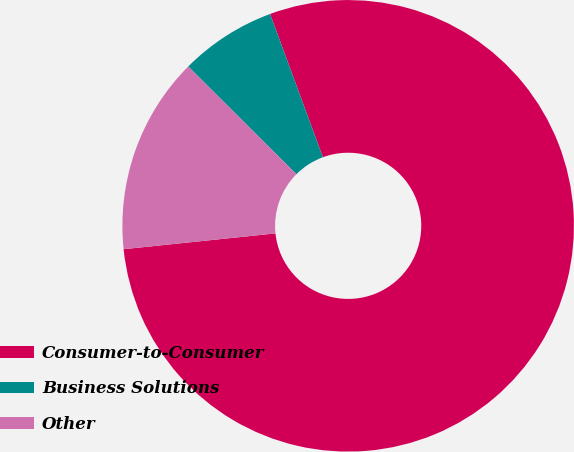<chart> <loc_0><loc_0><loc_500><loc_500><pie_chart><fcel>Consumer-to-Consumer<fcel>Business Solutions<fcel>Other<nl><fcel>78.97%<fcel>6.91%<fcel>14.12%<nl></chart> 